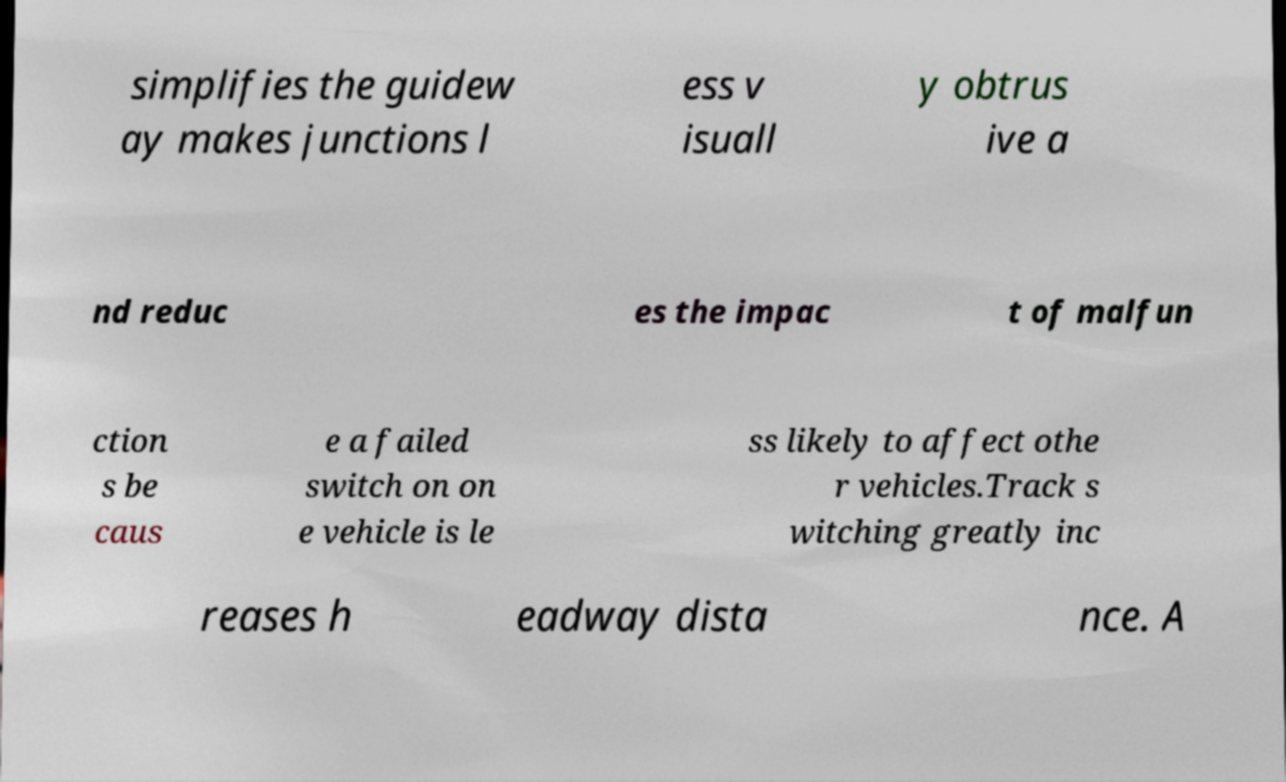Can you read and provide the text displayed in the image?This photo seems to have some interesting text. Can you extract and type it out for me? simplifies the guidew ay makes junctions l ess v isuall y obtrus ive a nd reduc es the impac t of malfun ction s be caus e a failed switch on on e vehicle is le ss likely to affect othe r vehicles.Track s witching greatly inc reases h eadway dista nce. A 